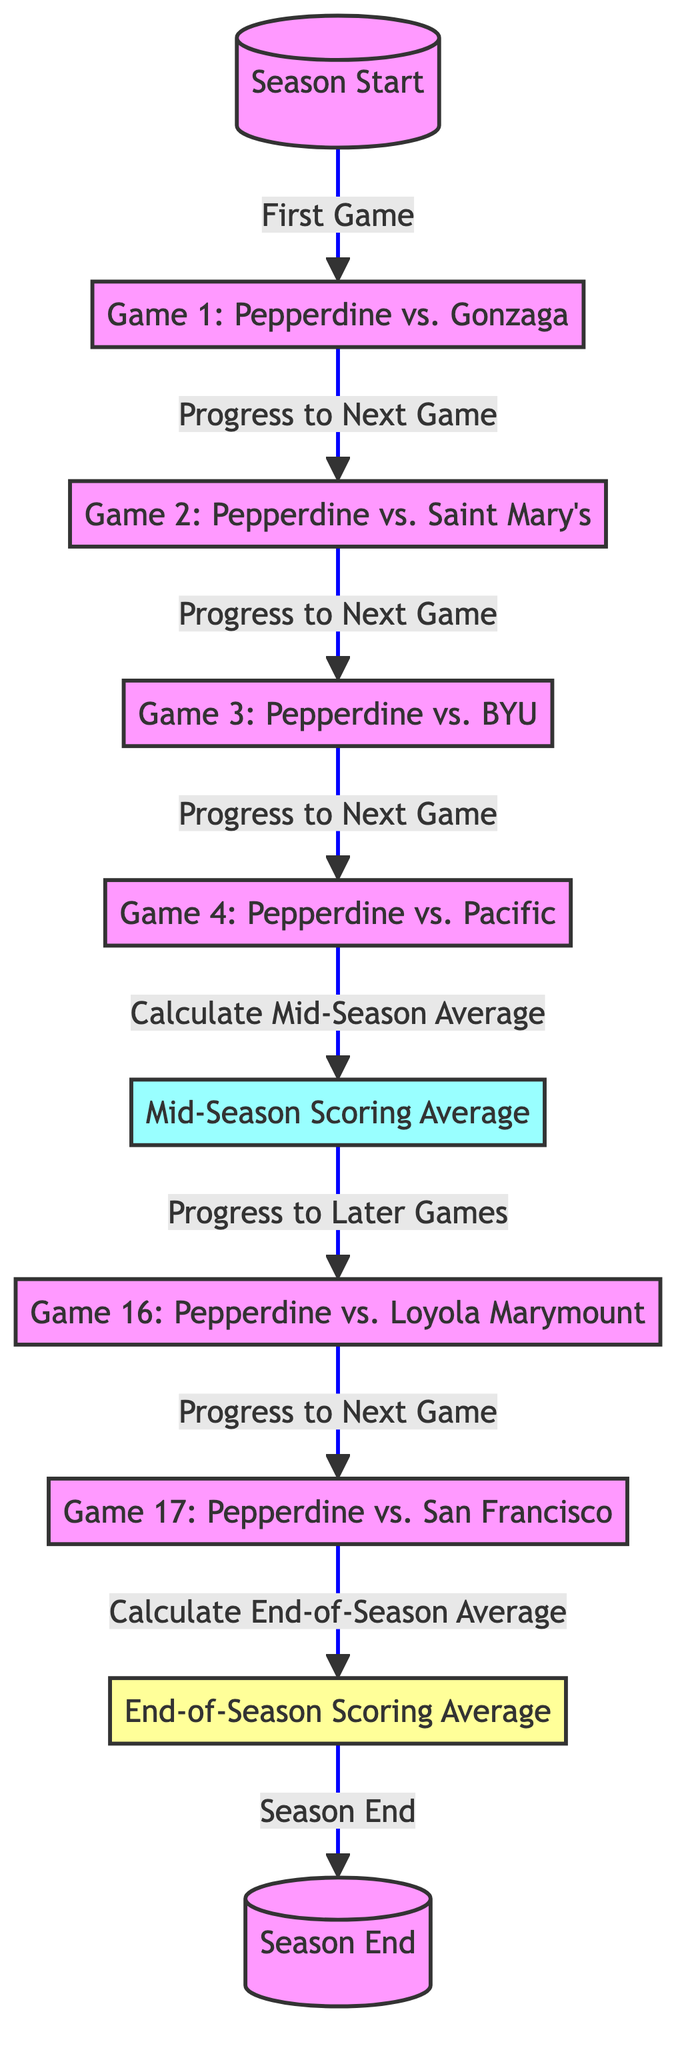What is the first game listed in the diagram? The diagram starts with the node labeled "Game 1: Pepperdine vs. Gonzaga," which is the first game in the sequence.
Answer: Game 1: Pepperdine vs. Gonzaga How many games are represented in this diagram? There are a total of 7 games listed in the diagram, including Game 1, Game 2, Game 3, Game 4, Game 16, and Game 17.
Answer: 7 What is the significance of the node "Mid-Season Scoring Average"? This node indicates the calculation of the scoring average after the first half of the season, specifically after Game 4.
Answer: Calculation of mid-season average Which node represents the end of the season? The diagram includes a node labeled "Season End" that indicates the termination of the season after all games have been played.
Answer: Season End What is the relationship between "Game 4" and "Mid-Season Scoring Average"? There is an edge labeled "Calculate Mid-Season Average" that connects "Game 4" to "Mid-Season Scoring Average," indicating that the average is computed after Game 4.
Answer: Calculate mid-season average Which games are considered later games after calculating the mid-season average? The diagram shows that after the "Mid-Season Scoring Average," the next game is "Game 16," which indicates the progression to later games after mid-season.
Answer: Game 16 How many edges are in the diagram? By counting the arrows or edges that connect the nodes, there are a total of 8 edges linking all the games and averages throughout the season flow.
Answer: 8 What happens after "Game 17"? After "Game 17," the flow connects to the "Calculate End-of-Season Average" node, showing that the average is calculated after the final game.
Answer: Calculate end-of-season average What does the label on the edge from "game17" to "endSeasonAverage" describe? The edge is labeled "Calculate End-of-Season Average," which explains the action taken after playing Game 17 regarding scoring averages.
Answer: Calculate end-of-season average 